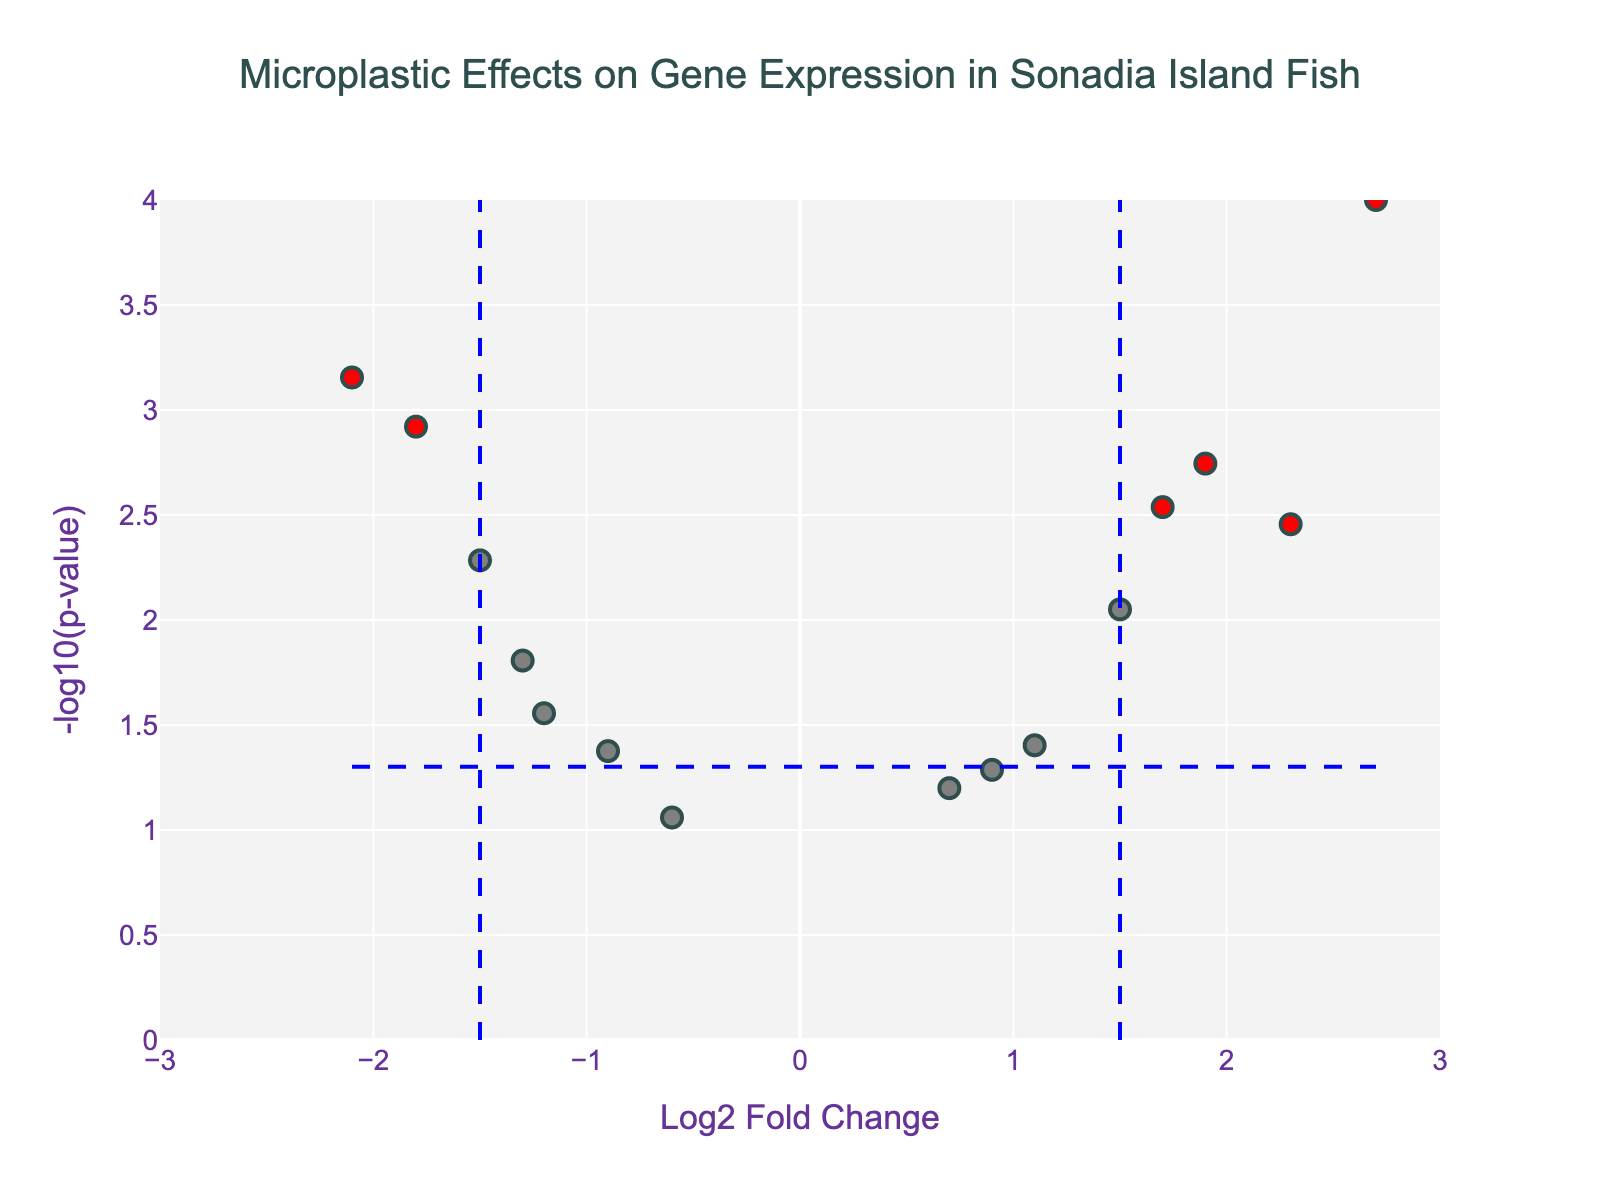What is the title of the figure? The title of the figure is usually placed at the top and describes the main topic of the plot. From the description provided, the title is "Microplastic Effects on Gene Expression in Sonadia Island Fish."
Answer: Microplastic Effects on Gene Expression in Sonadia Island Fish What do the x and y-axes represent? The x-axis represents "Log2 Fold Change" which shows changes in gene expression levels, while the y-axis represents "-log10(p-value)" which indicates the significance of the changes.
Answer: Log2 Fold Change and -log10(p-value) Which gene has the highest -log10(p-value)? The gene with the highest -log10(p-value) will be the point highest on the y-axis. From the data, the gene "Gerres_filamentosus_AChE" has the lowest p-value (0.0001) and therefore the highest -log10(p-value).
Answer: Gerres_filamentosus_AChE Which genes are marked in red? Genes are marked in red if their Log2FoldChange is greater than 1.5 or less than -1.5 and their p-value is less than 0.05. The genes that meet these criteria are: "Platax_orbicularis_HSP70," "Epinephelus_fuscoguttatus_CYP1A," "Sphyraena_jello_CAT," "Lutjanus_johnii_IL1B," "Gerres_filamentosus_AChE," and "Megalaspis_cordyla_GSTR."
Answer: Platax_orbicularis_HSP70, Epinephelus_fuscoguttatus_CYP1A, Sphyraena_jello_CAT, Lutjanus_johnii_IL1B, Gerres_filamentosus_AChE, Megalaspis_cordyla_GSTR What is the Log2FoldChange and p-value of "Sillago_sihama_HSP90"? The hover text provides information when you hover over points. From the data, "Sillago_sihama_HSP90" has a Log2FoldChange of 1.7 and a p-value of 0.0029.
Answer: 1.7 and 0.0029 What is the horizontal line representing in the plot? The horizontal line represents the p-value threshold (p = 0.05), corresponding to -log10(0.05). This line shows which points have significant p-values below 0.05.
Answer: -log10(0.05) Which gene shows the largest decrease in expression (negative Log2FoldChange)? The gene with the most negative Log2FoldChange is the one farthest to the left on the x-axis. From the data, "Lutjanus_johnii_IL1B" has the largest decrease in expression with a Log2FoldChange of -2.1.
Answer: Lutjanus_johnii_IL1B Are there more genes with increased expression (positive Log2FoldChange) or decreased expression (negative Log2FoldChange)? Count the number of genes with positive Log2FoldChange (greater than 0) and those with negative Log2FoldChange (less than 0). From the data:
Positive Log2FoldChange: 7 (Epinephelus_fuscoguttatus_CYP1A, Scarus_ghobban_SOD, Carangoides_malabaricus_GST, Sphyraena_jello_CAT, Eleutheronema_tetradactylum_TNF, Gerres_filamentosus_AChE, Sillago_sihama_HSP90).
Negative Log2FoldChange: 8 (Platax_orbicularis_HSP70, Lates_calcarifer_VTG, Plectorhinchus_gibbosus_MT, Lutjanus_johnii_IL1B, Pomadasys_argenteus_GPX, Megalaspis_cordyla_GSTR, Arius_tenuispinis_MMP9).
So, there are more genes with decreased expression.
Answer: Decreased expression Which genes have a p-value less than 0.01 but are not marked in red? For genes to not be marked red but have a p-value less than 0.01, they must not meet the Log2FoldChange criterion. From the data, "Scarus_ghobban_SOD" has a p-value of 0.0089 but its Log2FoldChange is 1.5, not more than 1.5.
Answer: Scarus_ghobban_SOD 